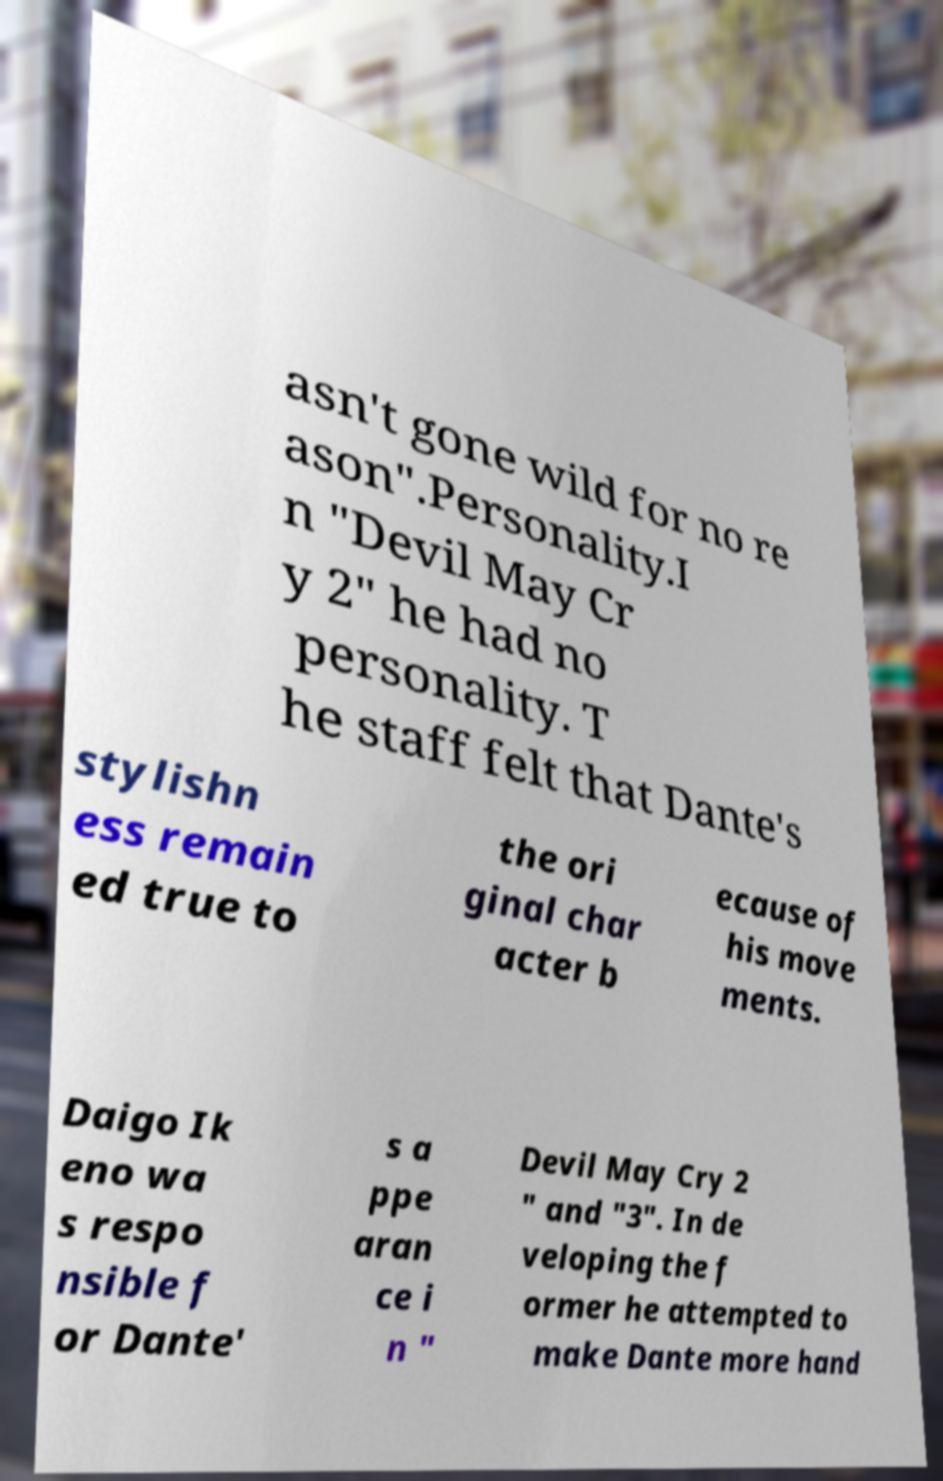Can you read and provide the text displayed in the image?This photo seems to have some interesting text. Can you extract and type it out for me? asn't gone wild for no re ason".Personality.I n "Devil May Cr y 2" he had no personality. T he staff felt that Dante's stylishn ess remain ed true to the ori ginal char acter b ecause of his move ments. Daigo Ik eno wa s respo nsible f or Dante' s a ppe aran ce i n " Devil May Cry 2 " and "3". In de veloping the f ormer he attempted to make Dante more hand 